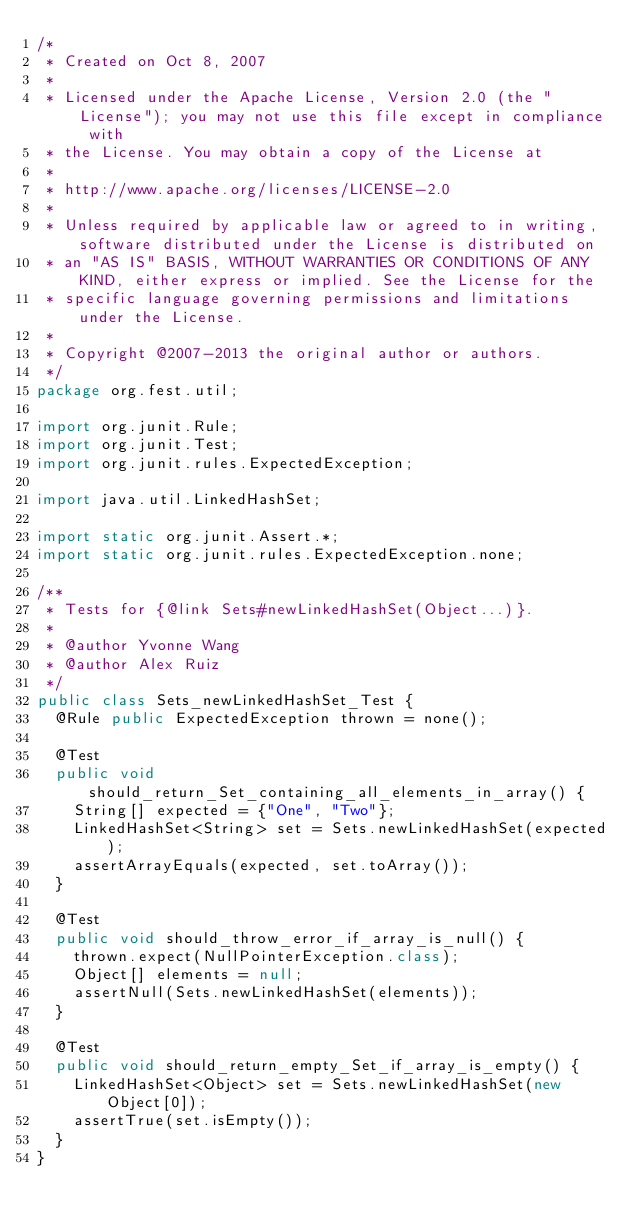<code> <loc_0><loc_0><loc_500><loc_500><_Java_>/*
 * Created on Oct 8, 2007
 * 
 * Licensed under the Apache License, Version 2.0 (the "License"); you may not use this file except in compliance with
 * the License. You may obtain a copy of the License at
 * 
 * http://www.apache.org/licenses/LICENSE-2.0
 * 
 * Unless required by applicable law or agreed to in writing, software distributed under the License is distributed on
 * an "AS IS" BASIS, WITHOUT WARRANTIES OR CONDITIONS OF ANY KIND, either express or implied. See the License for the
 * specific language governing permissions and limitations under the License.
 * 
 * Copyright @2007-2013 the original author or authors.
 */
package org.fest.util;

import org.junit.Rule;
import org.junit.Test;
import org.junit.rules.ExpectedException;

import java.util.LinkedHashSet;

import static org.junit.Assert.*;
import static org.junit.rules.ExpectedException.none;

/**
 * Tests for {@link Sets#newLinkedHashSet(Object...)}.
 *
 * @author Yvonne Wang
 * @author Alex Ruiz
 */
public class Sets_newLinkedHashSet_Test {
  @Rule public ExpectedException thrown = none();

  @Test
  public void should_return_Set_containing_all_elements_in_array() {
    String[] expected = {"One", "Two"};
    LinkedHashSet<String> set = Sets.newLinkedHashSet(expected);
    assertArrayEquals(expected, set.toArray());
  }

  @Test
  public void should_throw_error_if_array_is_null() {
    thrown.expect(NullPointerException.class);
    Object[] elements = null;
    assertNull(Sets.newLinkedHashSet(elements));
  }

  @Test
  public void should_return_empty_Set_if_array_is_empty() {
    LinkedHashSet<Object> set = Sets.newLinkedHashSet(new Object[0]);
    assertTrue(set.isEmpty());
  }
}
</code> 